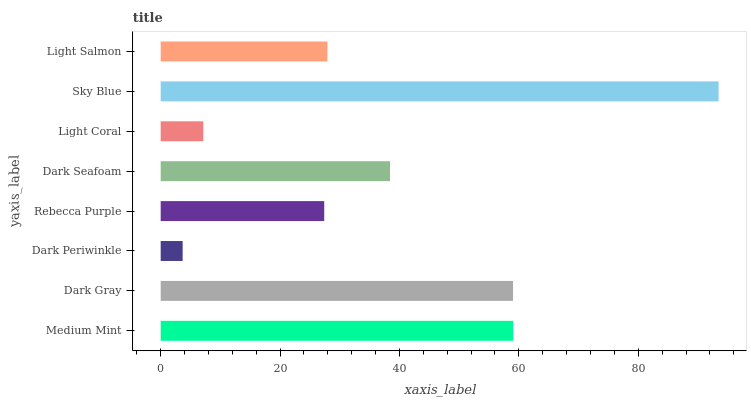Is Dark Periwinkle the minimum?
Answer yes or no. Yes. Is Sky Blue the maximum?
Answer yes or no. Yes. Is Dark Gray the minimum?
Answer yes or no. No. Is Dark Gray the maximum?
Answer yes or no. No. Is Medium Mint greater than Dark Gray?
Answer yes or no. Yes. Is Dark Gray less than Medium Mint?
Answer yes or no. Yes. Is Dark Gray greater than Medium Mint?
Answer yes or no. No. Is Medium Mint less than Dark Gray?
Answer yes or no. No. Is Dark Seafoam the high median?
Answer yes or no. Yes. Is Light Salmon the low median?
Answer yes or no. Yes. Is Dark Gray the high median?
Answer yes or no. No. Is Sky Blue the low median?
Answer yes or no. No. 